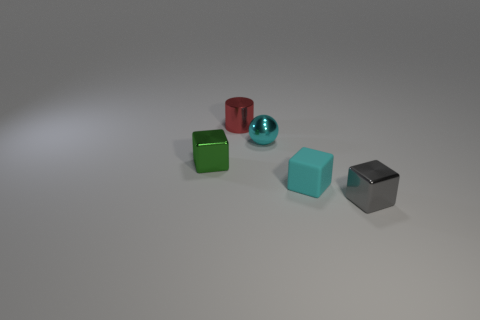There is a thing that is the same color as the shiny ball; what material is it?
Make the answer very short. Rubber. Is there a rubber cube of the same color as the tiny ball?
Your answer should be very brief. Yes. What shape is the cyan shiny object that is the same size as the cyan rubber block?
Give a very brief answer. Sphere. There is a matte thing that is the same color as the small shiny sphere; what is its shape?
Provide a short and direct response. Cube. Is the number of green metallic cubes that are left of the green shiny thing the same as the number of big yellow objects?
Ensure brevity in your answer.  Yes. There is a small object that is on the left side of the red metal cylinder to the left of the tiny cyan thing in front of the small green cube; what is it made of?
Your response must be concise. Metal. There is a green thing that is made of the same material as the tiny ball; what is its shape?
Make the answer very short. Cube. Is there any other thing that is the same color as the small shiny sphere?
Your answer should be very brief. Yes. How many cyan matte blocks are behind the metallic thing in front of the small metallic block behind the gray object?
Provide a short and direct response. 1. How many cyan objects are either cubes or tiny spheres?
Give a very brief answer. 2. 